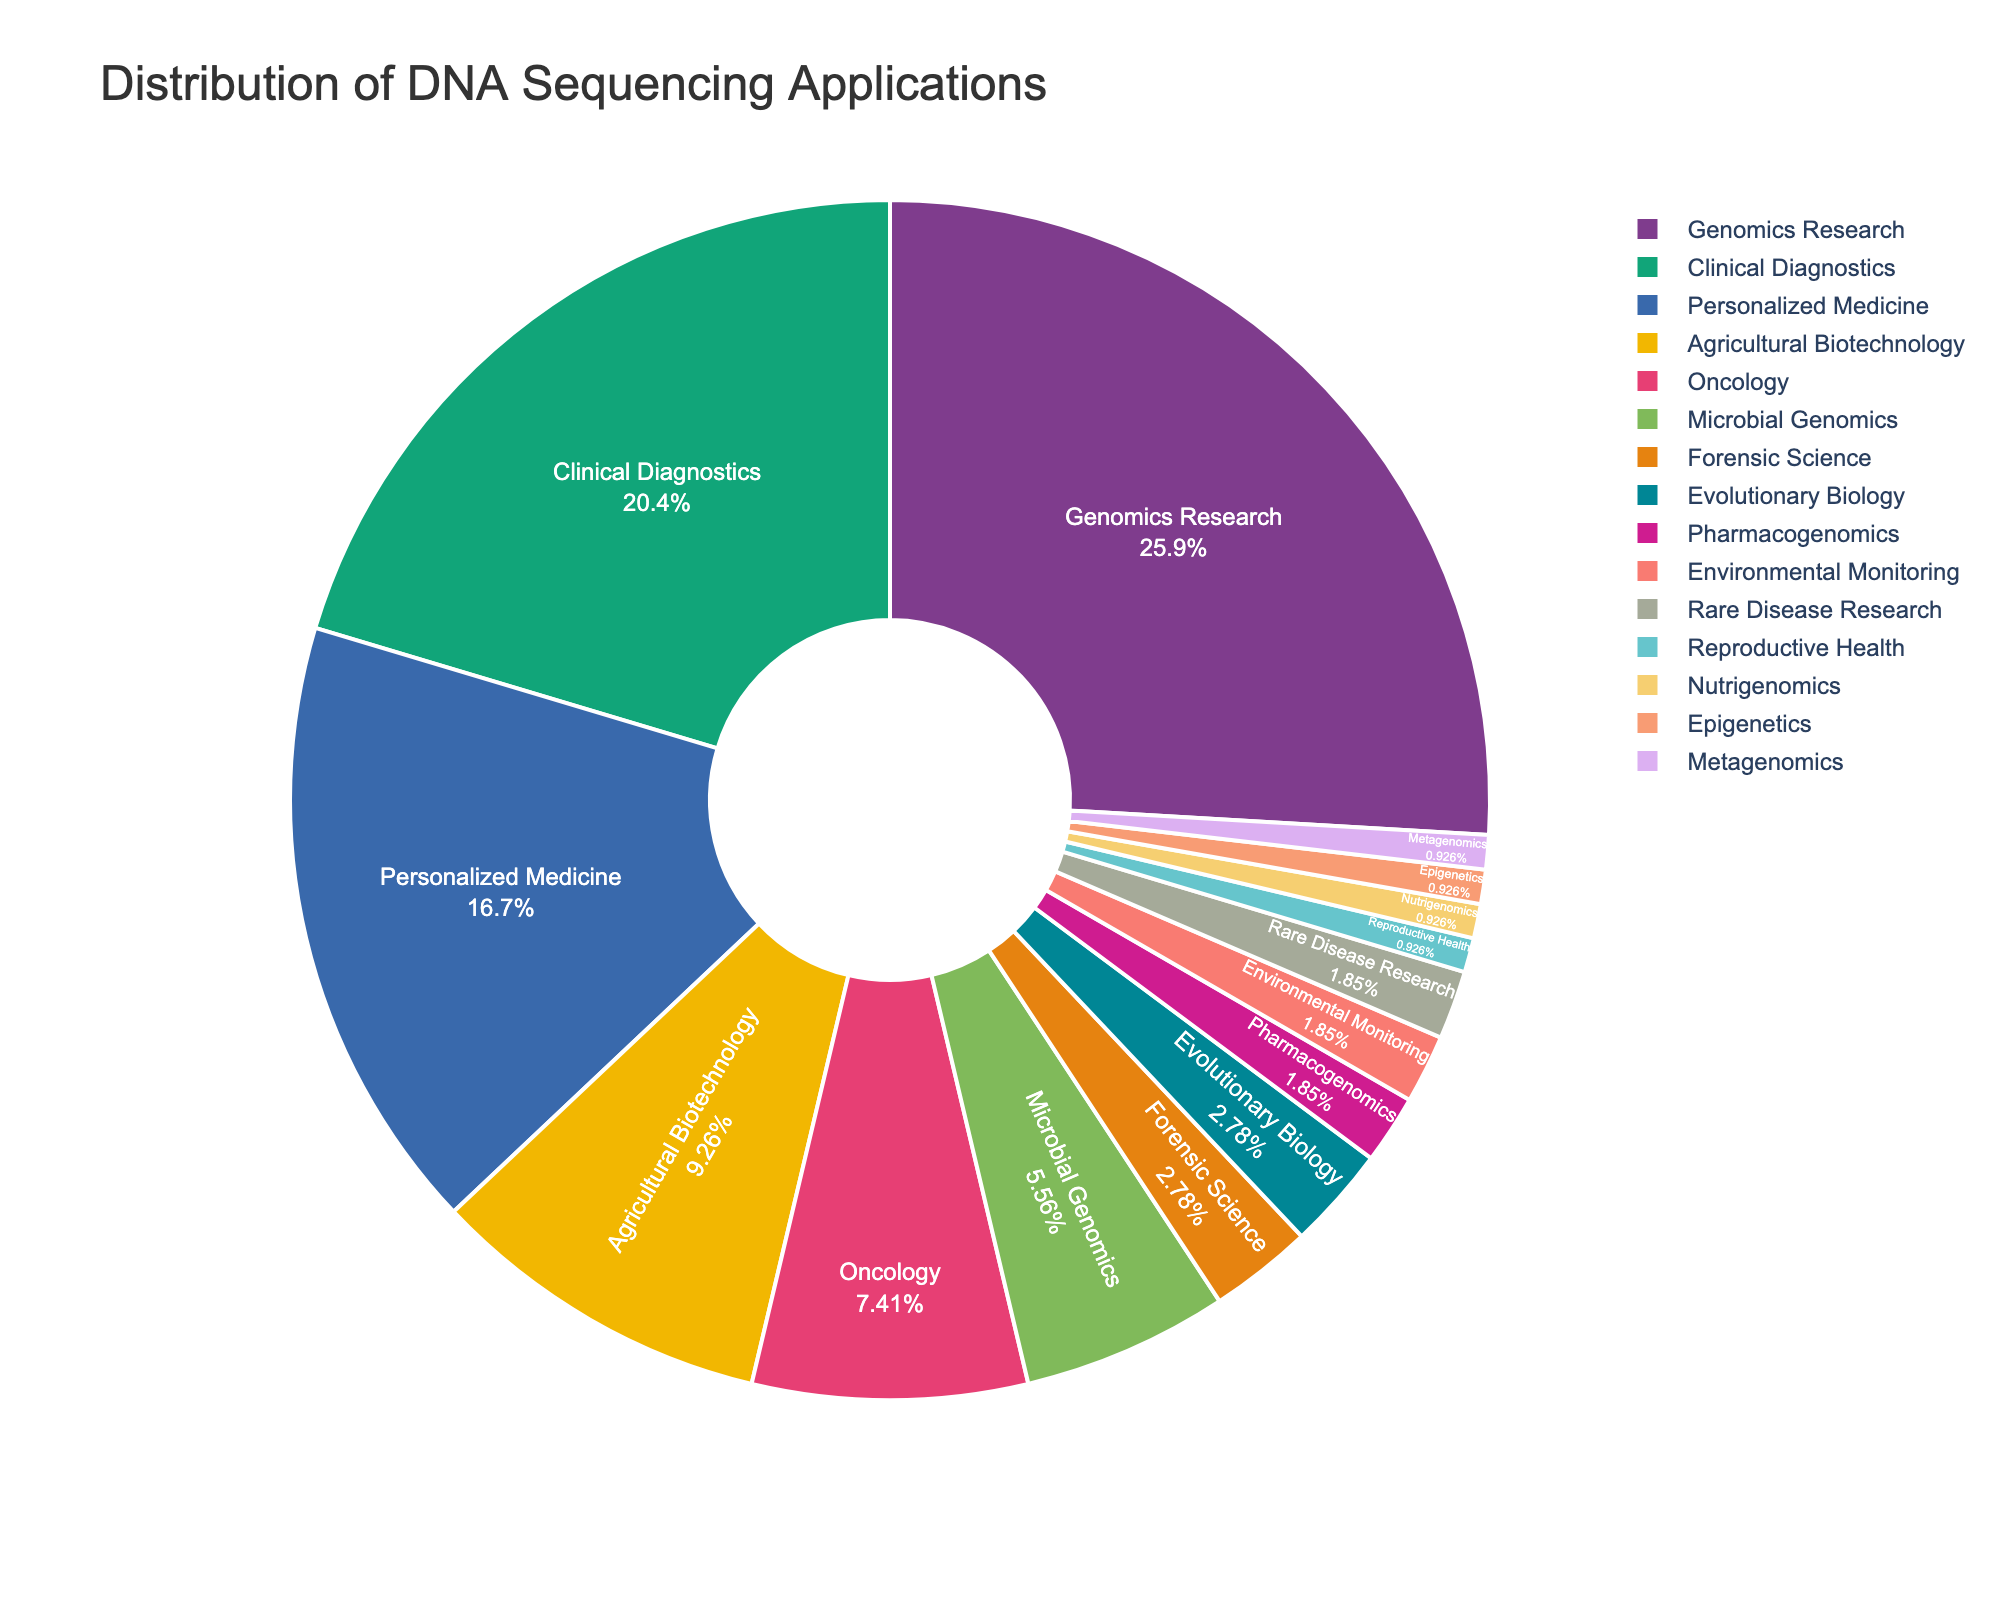What's the most common application of DNA sequencing? The largest segment of the pie chart represents the most common application. From the chart, "Genomics Research" occupies the largest portion.
Answer: Genomics Research Which field has the smallest share in DNA sequencing applications? The smallest segment of the pie chart represents the least common application. In this case, "Reproductive Health," "Nutrigenomics," "Epigenetics," and "Metagenomics" all have equal and smallest shares.
Answer: Reproductive Health, Nutrigenomics, Epigenetics, Metagenomics How much larger is the percentage of Genomics Research compared to Oncology? The percentage for Genomics Research is 28%, and for Oncology, it is 8%. The difference is 28% - 8%.
Answer: 20% What is the total percentage of applications in fields related to medicine (Clinical Diagnostics, Personalized Medicine, Oncology)? Adding the percentages for Clinical Diagnostics (22%), Personalized Medicine (18%), and Oncology (8%) gives us the total share. 22% + 18% + 8%.
Answer: 48% Does Personalized Medicine have more or less percentage than Agricultural Biotechnology? By comparing the segments, Personalized Medicine has 18%, while Agricultural Biotechnology has 10%.
Answer: More What is the combined percentage of the three least common applications? Adding the percentages for Reproductive Health (1%), Nutrigenomics (1%), Epigenetics (1%), and Metagenomics (1%) gives us the total share.
Answer: 4% Which two fields have equal shares in DNA sequencing applications? The pie chart shows equal segments for "Forensic Science" and "Evolutionary Biology," each with 3%.
Answer: Forensic Science, Evolutionary Biology What is the difference in percentage between Microbial Genomics and Pharmacogenomics? Microbial Genomics has 6%, and Pharmacogenomics has 2%. The difference is 6% - 2%.
Answer: 4% Which application fields together account for almost half of the total applications? Adding the three largest segments: Genomics Research (28%), Clinical Diagnostics (22%) gives us 50%.
Answer: Genomics Research, Clinical Diagnostics 